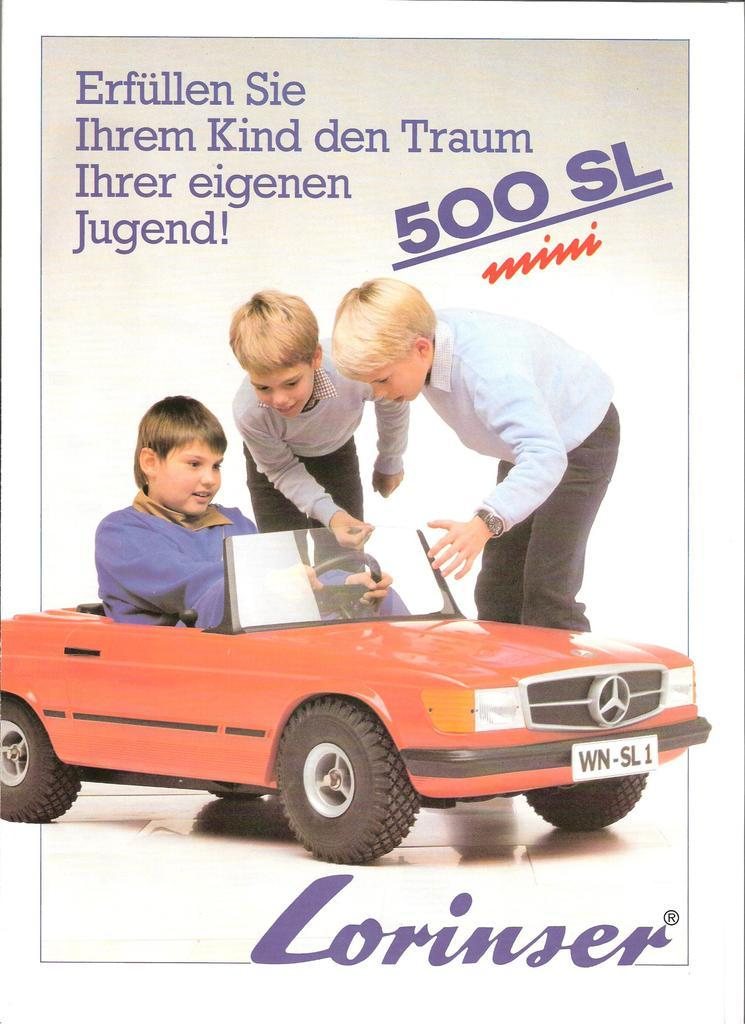What is present in the picture? There is a poster in the picture. What can be seen in the images on the poster? The poster contains images of persons and a vehicle. Is there any text on the poster? Yes, there is text on the poster. What type of glue is being offered in the alley depicted on the poster? There is no alley or glue present on the poster; it contains images of persons, a vehicle, and text. 